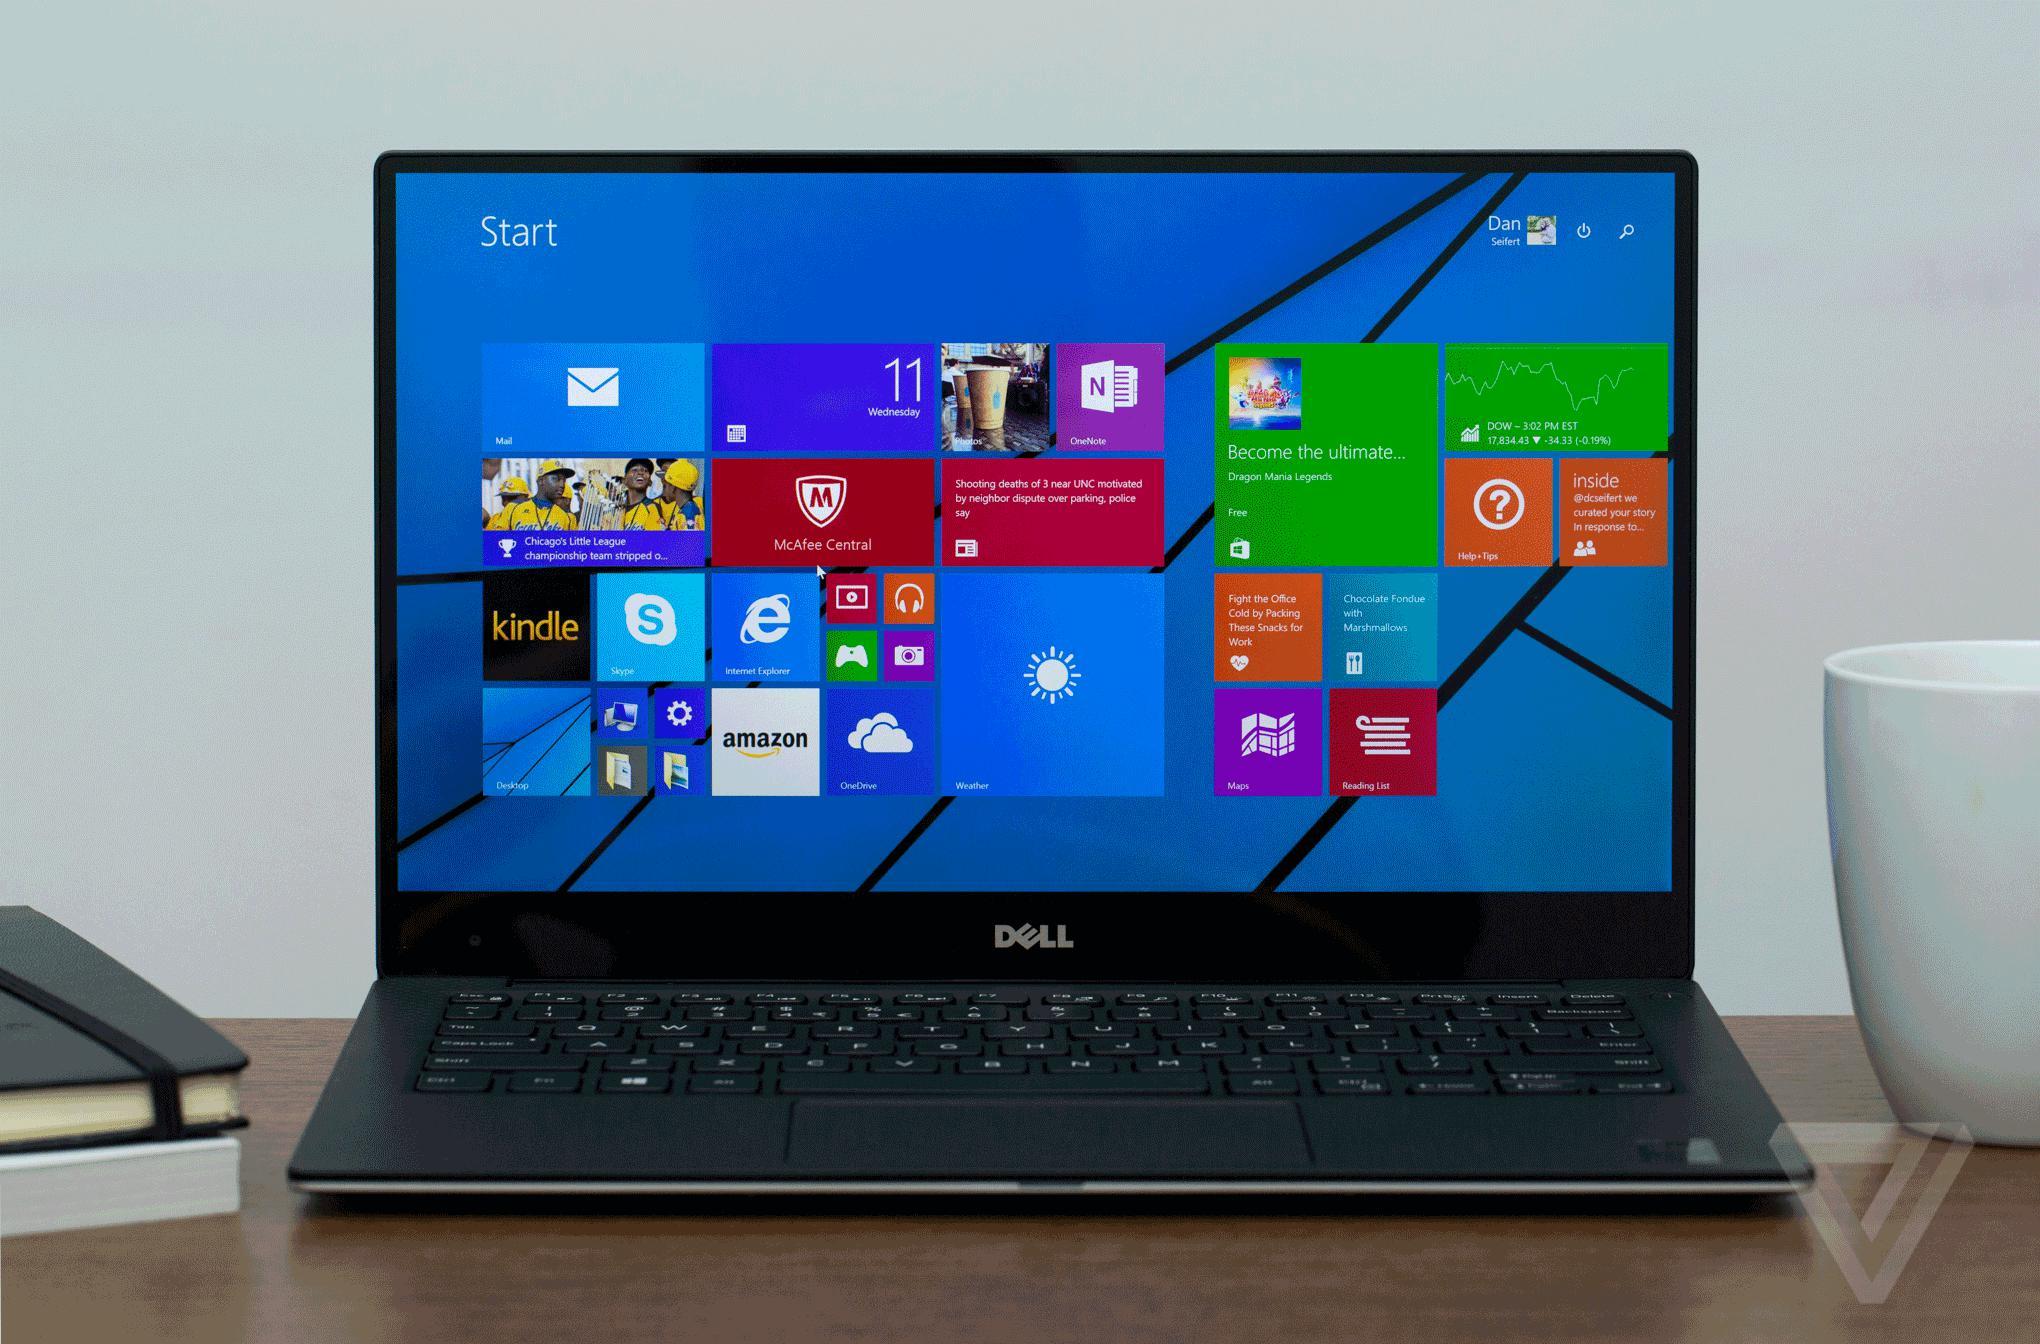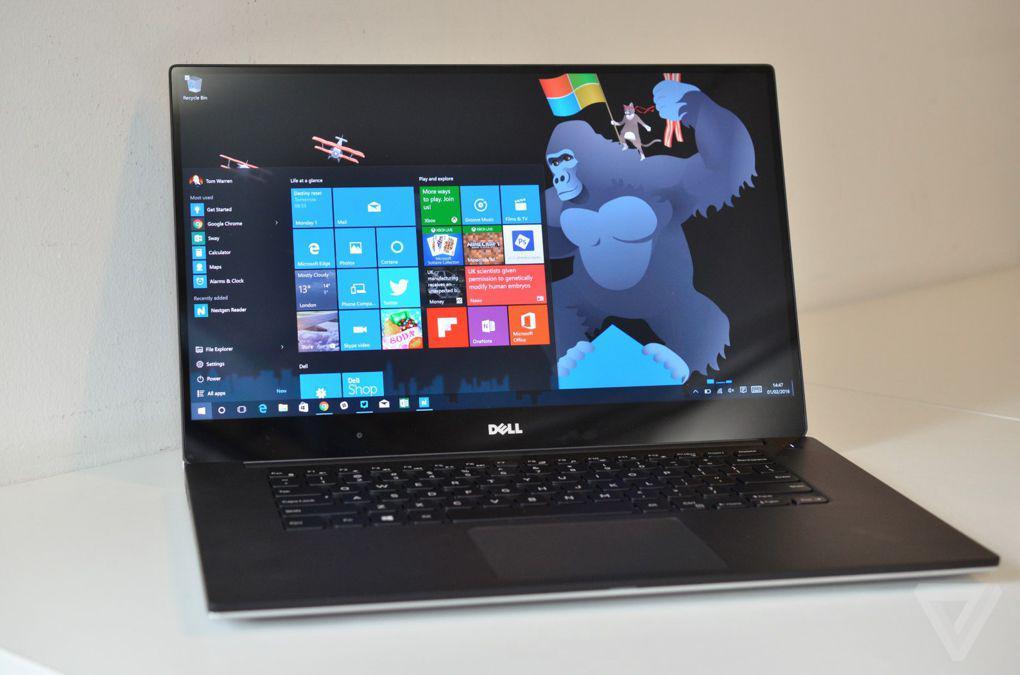The first image is the image on the left, the second image is the image on the right. For the images displayed, is the sentence "One of the pictures has more than one laptop." factually correct? Answer yes or no. No. The first image is the image on the left, the second image is the image on the right. Evaluate the accuracy of this statement regarding the images: "There are more computers in the image on the left.". Is it true? Answer yes or no. No. 